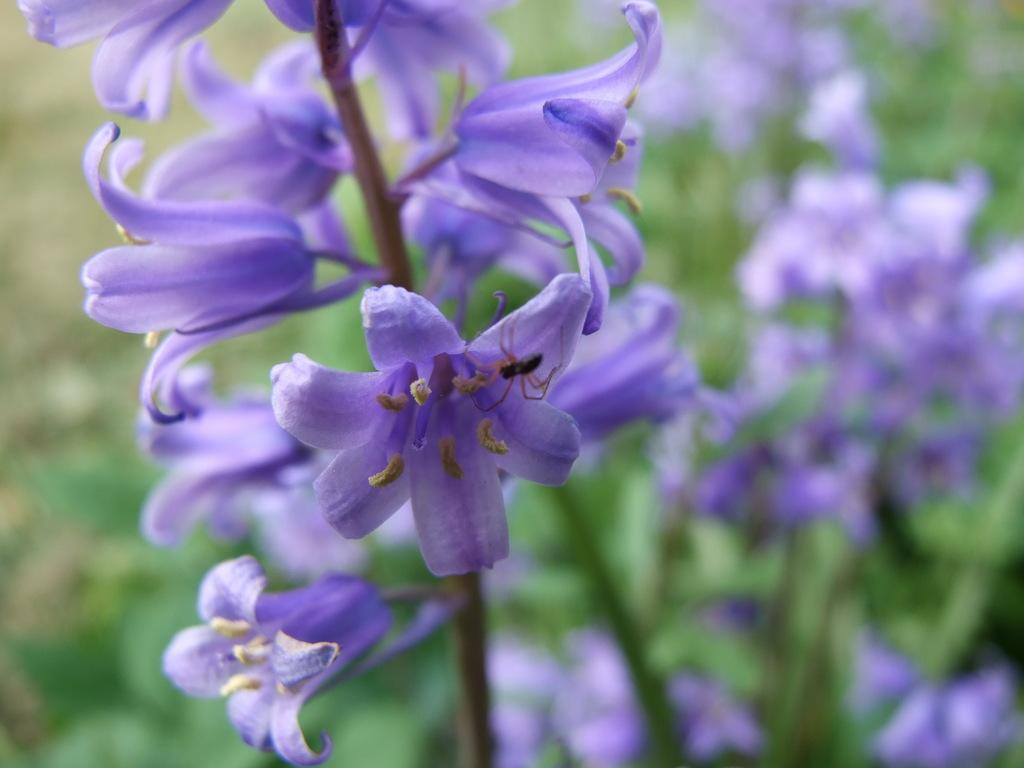What type of living organisms can be seen in the image? There are flowers and an insect in the image. Can you describe the interaction between the insect and the flowers? The insect is on one of the flowers in the image. What is the condition of the background in the image? The background of the image is blurred. What grade did the insect receive for its performance in the image? There is no indication of a grade or performance evaluation in the image, as it features flowers and an insect. 